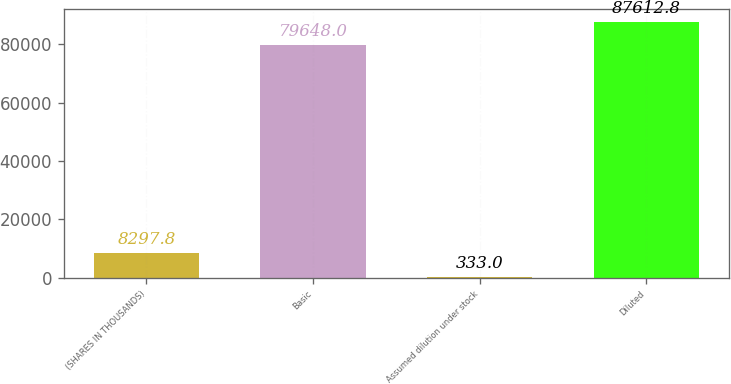Convert chart. <chart><loc_0><loc_0><loc_500><loc_500><bar_chart><fcel>(SHARES IN THOUSANDS)<fcel>Basic<fcel>Assumed dilution under stock<fcel>Diluted<nl><fcel>8297.8<fcel>79648<fcel>333<fcel>87612.8<nl></chart> 